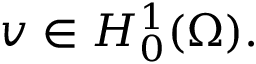<formula> <loc_0><loc_0><loc_500><loc_500>v \in H _ { 0 } ^ { 1 } ( \Omega ) .</formula> 